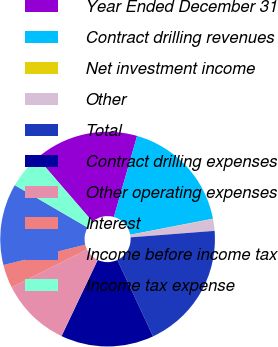Convert chart. <chart><loc_0><loc_0><loc_500><loc_500><pie_chart><fcel>Year Ended December 31<fcel>Contract drilling revenues<fcel>Net investment income<fcel>Other<fcel>Total<fcel>Contract drilling expenses<fcel>Other operating expenses<fcel>Interest<fcel>Income before income tax<fcel>Income tax expense<nl><fcel>15.77%<fcel>17.52%<fcel>0.04%<fcel>1.78%<fcel>19.26%<fcel>14.02%<fcel>10.52%<fcel>3.53%<fcel>12.27%<fcel>5.28%<nl></chart> 